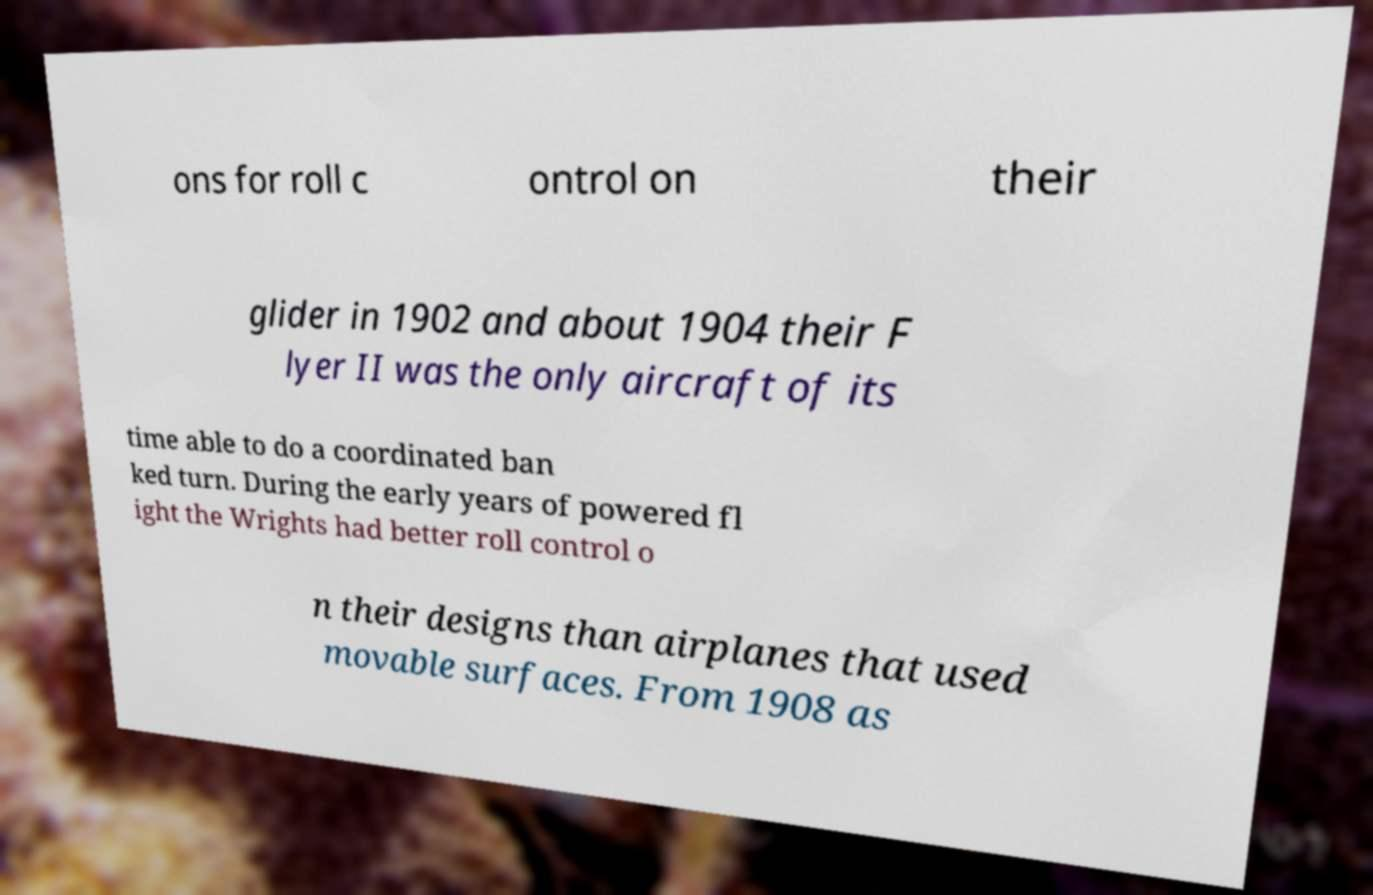Could you extract and type out the text from this image? ons for roll c ontrol on their glider in 1902 and about 1904 their F lyer II was the only aircraft of its time able to do a coordinated ban ked turn. During the early years of powered fl ight the Wrights had better roll control o n their designs than airplanes that used movable surfaces. From 1908 as 